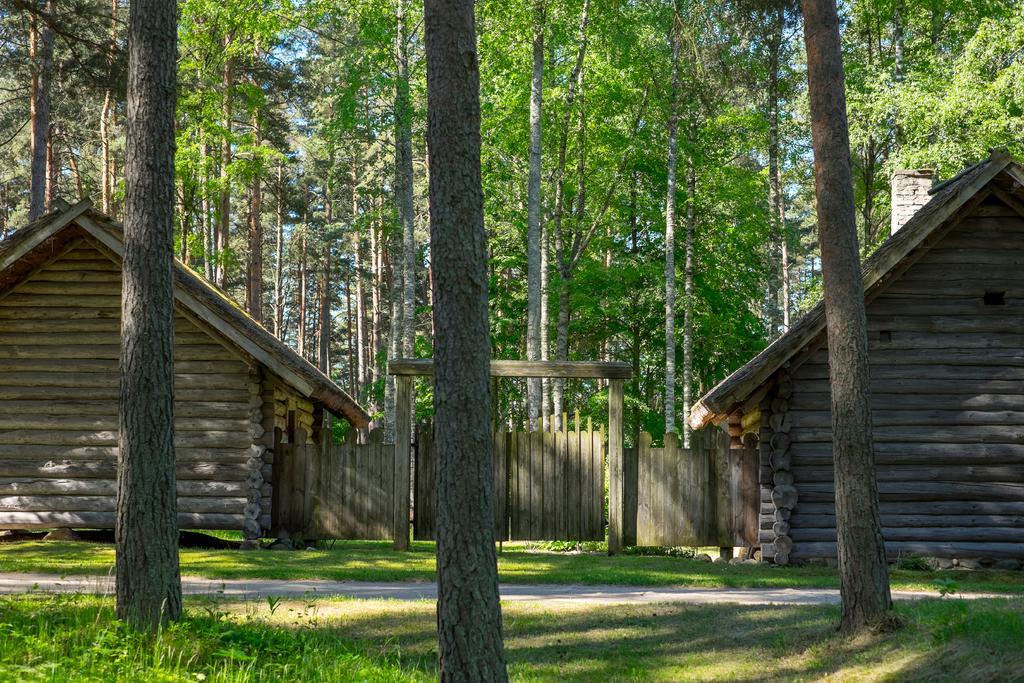Describe this image in one or two sentences. In the center of the image we can see a houses are present. In the background of the image a trees are there. At the bottom of the image road and grass are present. 